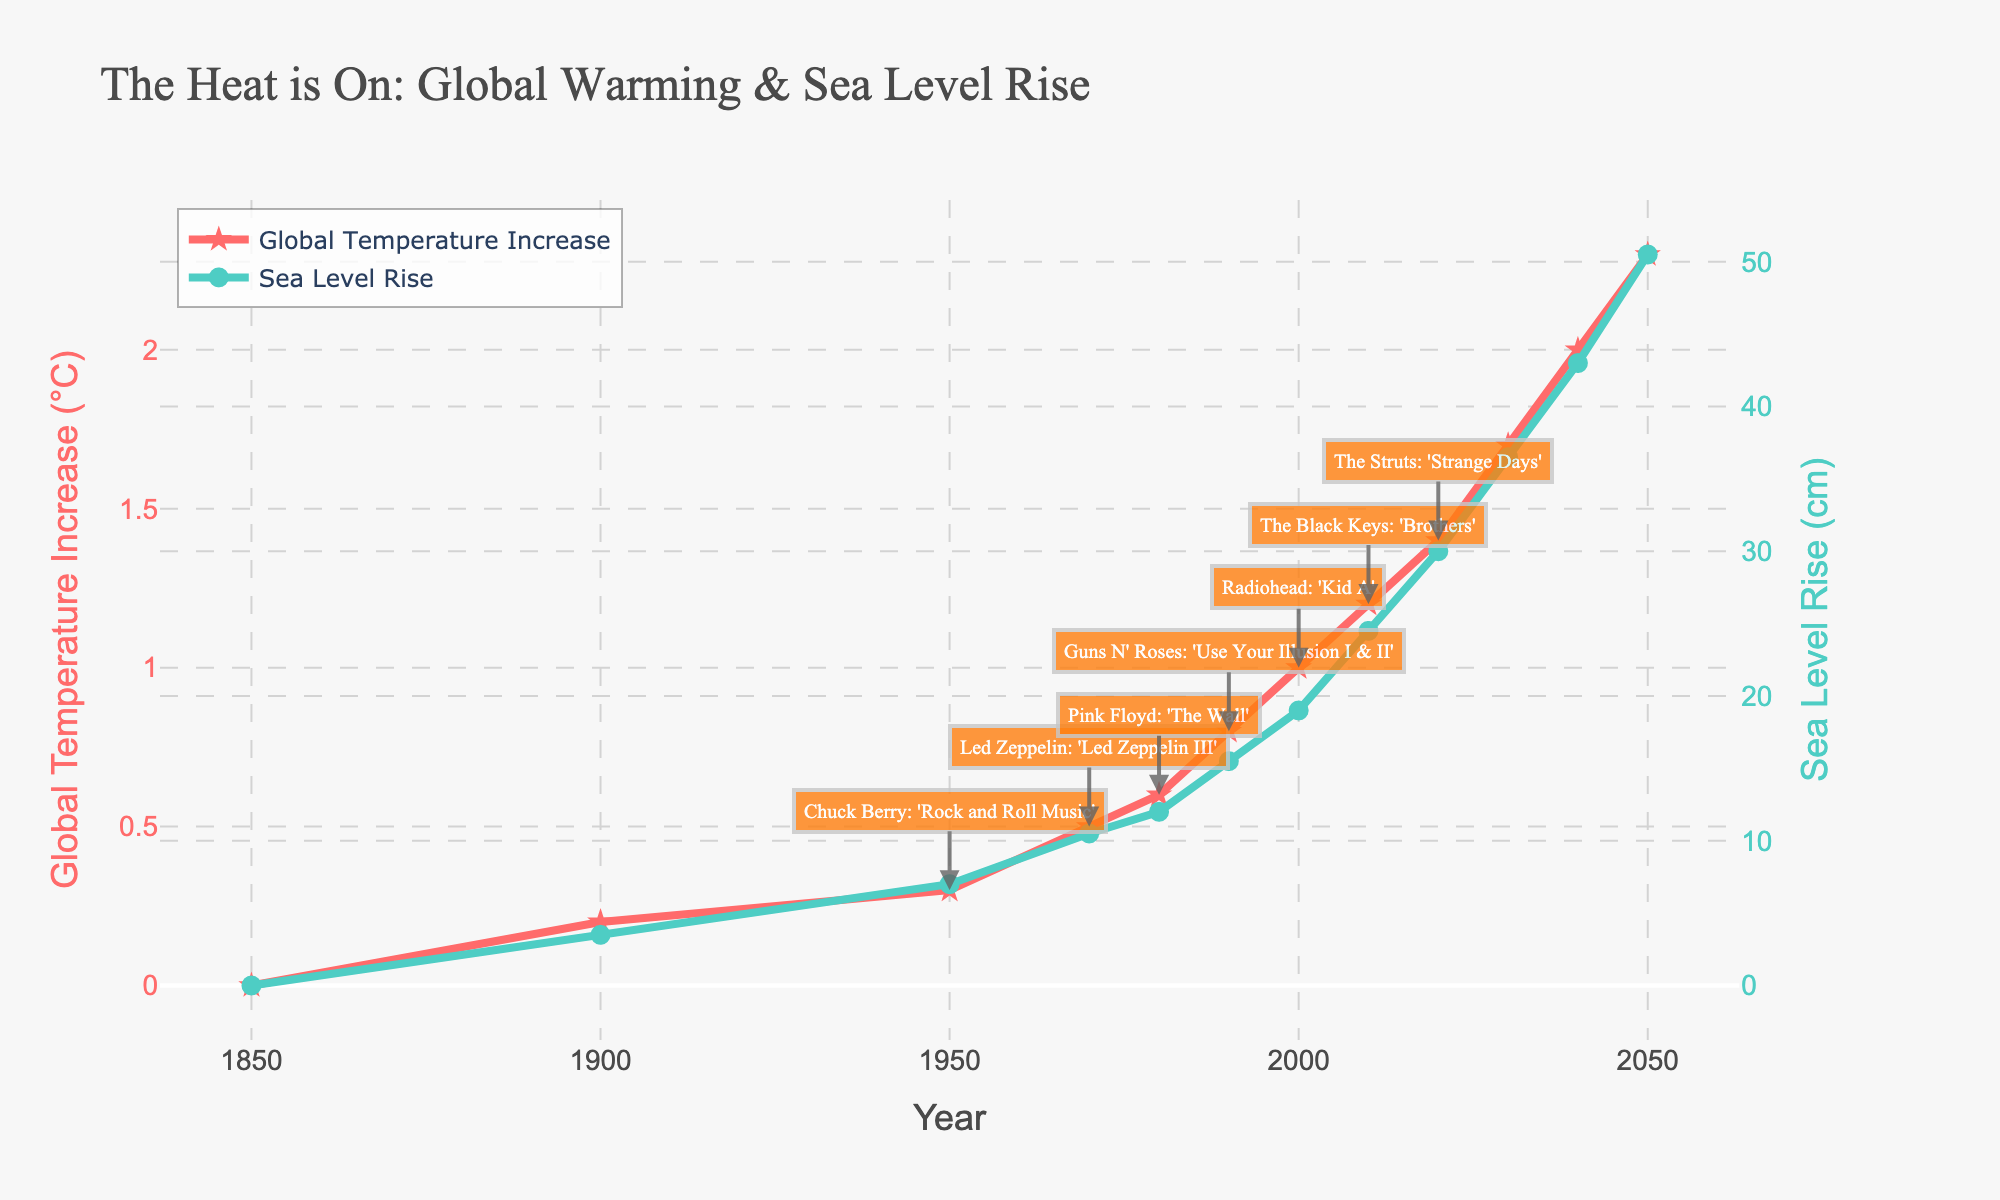What is the global temperature increase in the year Pink Floyd released 'The Wall'? To find the global temperature increase in 1980, check the data point for the year 1980. The annotated album 'Pink Floyd: The Wall' confirms the year. The corresponding temperature increase is noted as 0.6°C.
Answer: 0.6°C How much did the sea level rise between 1900 and 1950? To determine the sea level rise between 1900 and 1950, subtract the sea level rise in 1900 from that in 1950. Sea level rise in 1950 is 7.0 cm and in 1900 is 3.5 cm. 7.0 cm - 3.5 cm = 3.5 cm.
Answer: 3.5 cm Which year saw a 36.5 cm sea level rise and what was the global temperature increase in that year? Look for the year with a 36.5 cm sea level rise. According to the figure, this occurs in 2030. The global temperature increase in that year is 1.7°C.
Answer: 2030, 1.7°C How many years after the release of 'The Black Keys: Brothers' did the global temperature increase reach 1.4°C? 'The Black Keys: Brothers' was released in 2010, and the temperature increase reached 1.4°C in 2020. The difference is 2020 - 2010 = 10 years.
Answer: 10 years What is the difference in sea level rise between the year Led Zeppelin released 'Led Zeppelin III' and the year Radiohead released 'Kid A'? 'Led Zeppelin III' was released in 1970, and sea level rise in that year was 10.5 cm. 'Kid A' was released in 2000, and the sea level rise was 19.0 cm. The difference is 19.0 cm - 10.5 cm = 8.5 cm.
Answer: 8.5 cm In which decade did the sea level first rise above 10 cm? Check the decade when the sea level exceeds 10 cm for the first time. From the data, the sea level in 1970 (10.5 cm) exceeds 10 cm. Therefore, it first rose above 10 cm in the 1970s.
Answer: 1970s Compare the global temperature increase and sea level rise between 1990 and 2010. In 1990, the global temperature increased by 0.8°C and sea level rose by 15.5 cm. In 2010, the temperature increased by 1.2°C and sea level rose by 24.5 cm. The increase from 1990 to 2010 for temperature is 1.2°C - 0.8°C = 0.4°C. For sea level, it's 24.5 cm - 15.5 cm = 9.0 cm.
Answer: 0.4°C, 9.0 cm What was the pattern of global temperature increase after the release of 'Guns N' Roses: Use Your Illusion I & II'? 'Guns N' Roses: Use Your Illusion I & II' was released in 1990. Observing the data, the global temperature steadily increased: 0.8°C in 1990, 1.0°C in 2000, 1.2°C in 2010, 1.4°C in 2020, reaching 1.7°C in 2030.
Answer: Steady increase 